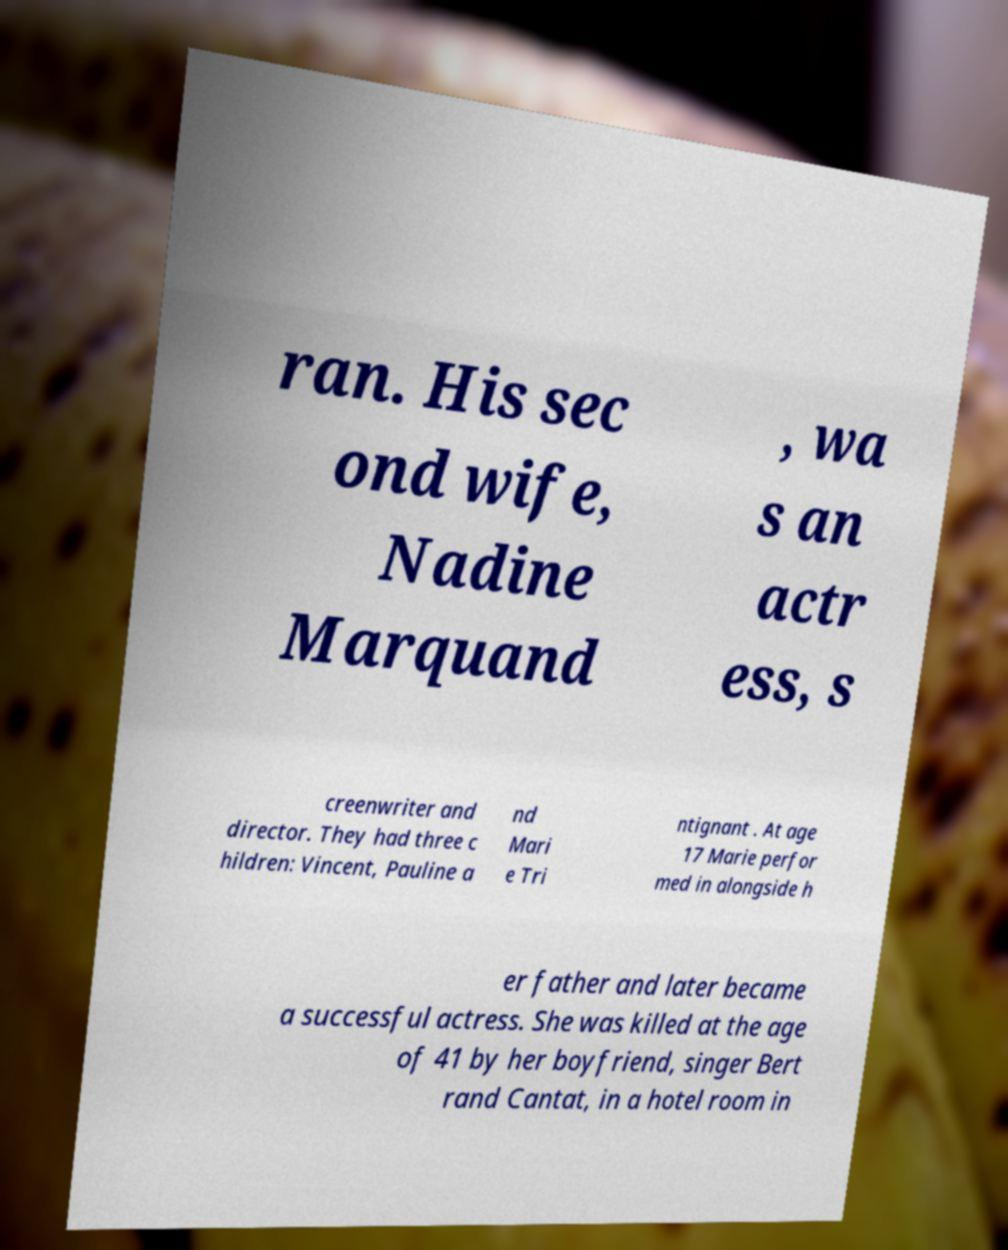Could you extract and type out the text from this image? ran. His sec ond wife, Nadine Marquand , wa s an actr ess, s creenwriter and director. They had three c hildren: Vincent, Pauline a nd Mari e Tri ntignant . At age 17 Marie perfor med in alongside h er father and later became a successful actress. She was killed at the age of 41 by her boyfriend, singer Bert rand Cantat, in a hotel room in 